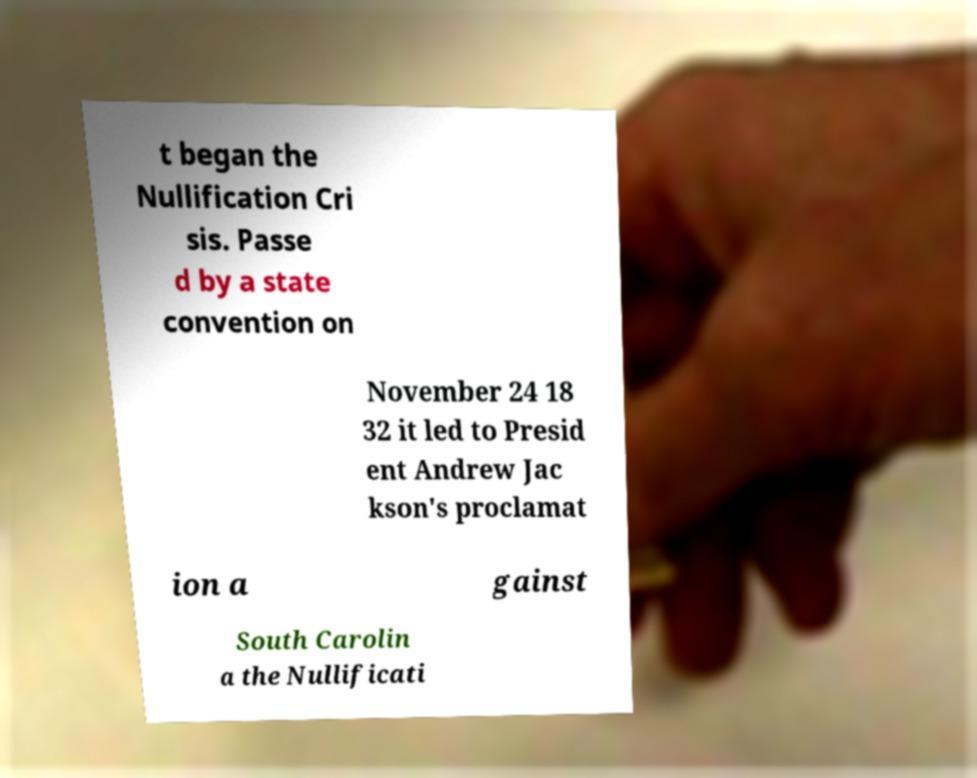Can you accurately transcribe the text from the provided image for me? t began the Nullification Cri sis. Passe d by a state convention on November 24 18 32 it led to Presid ent Andrew Jac kson's proclamat ion a gainst South Carolin a the Nullificati 